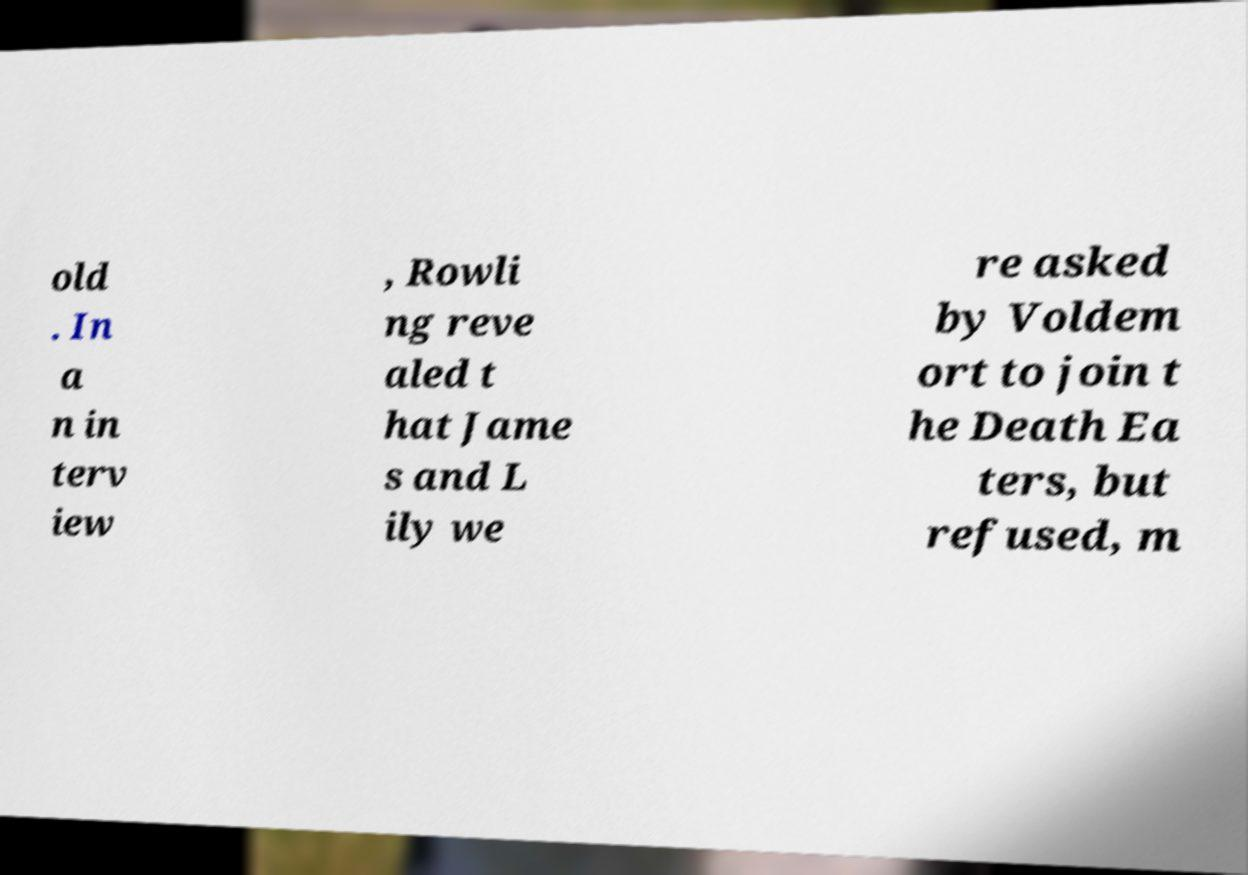Please read and relay the text visible in this image. What does it say? old . In a n in terv iew , Rowli ng reve aled t hat Jame s and L ily we re asked by Voldem ort to join t he Death Ea ters, but refused, m 